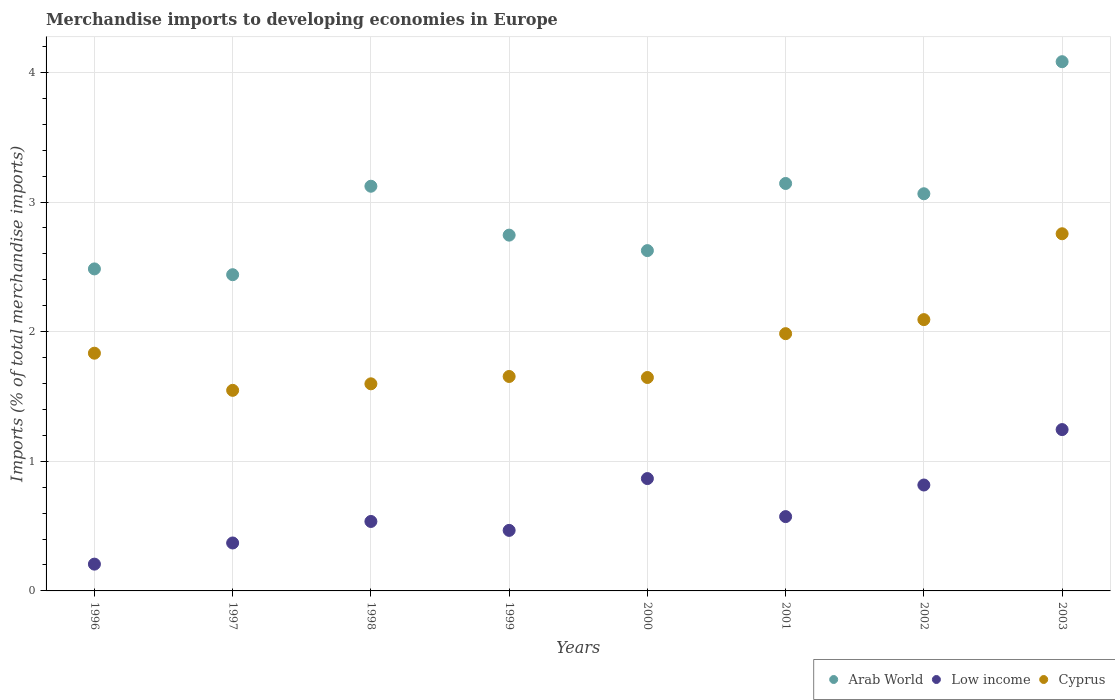How many different coloured dotlines are there?
Offer a very short reply. 3. What is the percentage total merchandise imports in Arab World in 1997?
Your answer should be compact. 2.44. Across all years, what is the maximum percentage total merchandise imports in Cyprus?
Give a very brief answer. 2.76. Across all years, what is the minimum percentage total merchandise imports in Low income?
Your answer should be compact. 0.21. In which year was the percentage total merchandise imports in Low income minimum?
Provide a short and direct response. 1996. What is the total percentage total merchandise imports in Cyprus in the graph?
Ensure brevity in your answer.  15.11. What is the difference between the percentage total merchandise imports in Low income in 1996 and that in 2001?
Offer a very short reply. -0.37. What is the difference between the percentage total merchandise imports in Low income in 2002 and the percentage total merchandise imports in Cyprus in 1996?
Ensure brevity in your answer.  -1.02. What is the average percentage total merchandise imports in Low income per year?
Ensure brevity in your answer.  0.64. In the year 2003, what is the difference between the percentage total merchandise imports in Low income and percentage total merchandise imports in Cyprus?
Your answer should be compact. -1.51. What is the ratio of the percentage total merchandise imports in Low income in 1996 to that in 2003?
Make the answer very short. 0.17. Is the percentage total merchandise imports in Cyprus in 2001 less than that in 2003?
Offer a terse response. Yes. Is the difference between the percentage total merchandise imports in Low income in 1999 and 2003 greater than the difference between the percentage total merchandise imports in Cyprus in 1999 and 2003?
Provide a short and direct response. Yes. What is the difference between the highest and the second highest percentage total merchandise imports in Low income?
Offer a terse response. 0.38. What is the difference between the highest and the lowest percentage total merchandise imports in Low income?
Your response must be concise. 1.04. In how many years, is the percentage total merchandise imports in Cyprus greater than the average percentage total merchandise imports in Cyprus taken over all years?
Keep it short and to the point. 3. Is it the case that in every year, the sum of the percentage total merchandise imports in Arab World and percentage total merchandise imports in Cyprus  is greater than the percentage total merchandise imports in Low income?
Keep it short and to the point. Yes. Does the percentage total merchandise imports in Arab World monotonically increase over the years?
Keep it short and to the point. No. How many dotlines are there?
Your answer should be compact. 3. How many years are there in the graph?
Ensure brevity in your answer.  8. Does the graph contain any zero values?
Ensure brevity in your answer.  No. Where does the legend appear in the graph?
Offer a very short reply. Bottom right. What is the title of the graph?
Your answer should be very brief. Merchandise imports to developing economies in Europe. Does "St. Martin (French part)" appear as one of the legend labels in the graph?
Provide a succinct answer. No. What is the label or title of the Y-axis?
Offer a terse response. Imports (% of total merchandise imports). What is the Imports (% of total merchandise imports) of Arab World in 1996?
Give a very brief answer. 2.48. What is the Imports (% of total merchandise imports) of Low income in 1996?
Offer a very short reply. 0.21. What is the Imports (% of total merchandise imports) in Cyprus in 1996?
Your answer should be compact. 1.83. What is the Imports (% of total merchandise imports) in Arab World in 1997?
Give a very brief answer. 2.44. What is the Imports (% of total merchandise imports) of Low income in 1997?
Keep it short and to the point. 0.37. What is the Imports (% of total merchandise imports) in Cyprus in 1997?
Give a very brief answer. 1.55. What is the Imports (% of total merchandise imports) of Arab World in 1998?
Offer a very short reply. 3.12. What is the Imports (% of total merchandise imports) in Low income in 1998?
Offer a very short reply. 0.54. What is the Imports (% of total merchandise imports) of Cyprus in 1998?
Provide a short and direct response. 1.6. What is the Imports (% of total merchandise imports) in Arab World in 1999?
Offer a very short reply. 2.74. What is the Imports (% of total merchandise imports) in Low income in 1999?
Give a very brief answer. 0.47. What is the Imports (% of total merchandise imports) in Cyprus in 1999?
Your answer should be compact. 1.65. What is the Imports (% of total merchandise imports) in Arab World in 2000?
Offer a very short reply. 2.63. What is the Imports (% of total merchandise imports) in Low income in 2000?
Ensure brevity in your answer.  0.87. What is the Imports (% of total merchandise imports) of Cyprus in 2000?
Keep it short and to the point. 1.65. What is the Imports (% of total merchandise imports) of Arab World in 2001?
Keep it short and to the point. 3.14. What is the Imports (% of total merchandise imports) of Low income in 2001?
Make the answer very short. 0.57. What is the Imports (% of total merchandise imports) of Cyprus in 2001?
Offer a very short reply. 1.98. What is the Imports (% of total merchandise imports) of Arab World in 2002?
Your answer should be compact. 3.06. What is the Imports (% of total merchandise imports) of Low income in 2002?
Offer a very short reply. 0.82. What is the Imports (% of total merchandise imports) in Cyprus in 2002?
Your answer should be compact. 2.09. What is the Imports (% of total merchandise imports) in Arab World in 2003?
Make the answer very short. 4.08. What is the Imports (% of total merchandise imports) in Low income in 2003?
Your answer should be very brief. 1.24. What is the Imports (% of total merchandise imports) of Cyprus in 2003?
Ensure brevity in your answer.  2.76. Across all years, what is the maximum Imports (% of total merchandise imports) of Arab World?
Ensure brevity in your answer.  4.08. Across all years, what is the maximum Imports (% of total merchandise imports) of Low income?
Your answer should be very brief. 1.24. Across all years, what is the maximum Imports (% of total merchandise imports) of Cyprus?
Ensure brevity in your answer.  2.76. Across all years, what is the minimum Imports (% of total merchandise imports) in Arab World?
Ensure brevity in your answer.  2.44. Across all years, what is the minimum Imports (% of total merchandise imports) of Low income?
Make the answer very short. 0.21. Across all years, what is the minimum Imports (% of total merchandise imports) in Cyprus?
Your answer should be very brief. 1.55. What is the total Imports (% of total merchandise imports) of Arab World in the graph?
Offer a very short reply. 23.71. What is the total Imports (% of total merchandise imports) of Low income in the graph?
Offer a very short reply. 5.08. What is the total Imports (% of total merchandise imports) of Cyprus in the graph?
Provide a short and direct response. 15.11. What is the difference between the Imports (% of total merchandise imports) of Arab World in 1996 and that in 1997?
Offer a terse response. 0.04. What is the difference between the Imports (% of total merchandise imports) in Low income in 1996 and that in 1997?
Make the answer very short. -0.16. What is the difference between the Imports (% of total merchandise imports) of Cyprus in 1996 and that in 1997?
Your answer should be compact. 0.29. What is the difference between the Imports (% of total merchandise imports) of Arab World in 1996 and that in 1998?
Make the answer very short. -0.64. What is the difference between the Imports (% of total merchandise imports) of Low income in 1996 and that in 1998?
Your answer should be very brief. -0.33. What is the difference between the Imports (% of total merchandise imports) in Cyprus in 1996 and that in 1998?
Offer a very short reply. 0.24. What is the difference between the Imports (% of total merchandise imports) in Arab World in 1996 and that in 1999?
Keep it short and to the point. -0.26. What is the difference between the Imports (% of total merchandise imports) of Low income in 1996 and that in 1999?
Provide a succinct answer. -0.26. What is the difference between the Imports (% of total merchandise imports) of Cyprus in 1996 and that in 1999?
Your answer should be compact. 0.18. What is the difference between the Imports (% of total merchandise imports) of Arab World in 1996 and that in 2000?
Provide a succinct answer. -0.14. What is the difference between the Imports (% of total merchandise imports) of Low income in 1996 and that in 2000?
Your answer should be very brief. -0.66. What is the difference between the Imports (% of total merchandise imports) in Cyprus in 1996 and that in 2000?
Ensure brevity in your answer.  0.19. What is the difference between the Imports (% of total merchandise imports) of Arab World in 1996 and that in 2001?
Offer a very short reply. -0.66. What is the difference between the Imports (% of total merchandise imports) of Low income in 1996 and that in 2001?
Offer a terse response. -0.37. What is the difference between the Imports (% of total merchandise imports) of Cyprus in 1996 and that in 2001?
Give a very brief answer. -0.15. What is the difference between the Imports (% of total merchandise imports) in Arab World in 1996 and that in 2002?
Provide a succinct answer. -0.58. What is the difference between the Imports (% of total merchandise imports) in Low income in 1996 and that in 2002?
Keep it short and to the point. -0.61. What is the difference between the Imports (% of total merchandise imports) in Cyprus in 1996 and that in 2002?
Your answer should be very brief. -0.26. What is the difference between the Imports (% of total merchandise imports) of Arab World in 1996 and that in 2003?
Provide a short and direct response. -1.6. What is the difference between the Imports (% of total merchandise imports) of Low income in 1996 and that in 2003?
Ensure brevity in your answer.  -1.04. What is the difference between the Imports (% of total merchandise imports) in Cyprus in 1996 and that in 2003?
Provide a short and direct response. -0.92. What is the difference between the Imports (% of total merchandise imports) in Arab World in 1997 and that in 1998?
Your answer should be very brief. -0.68. What is the difference between the Imports (% of total merchandise imports) of Low income in 1997 and that in 1998?
Your answer should be compact. -0.17. What is the difference between the Imports (% of total merchandise imports) in Cyprus in 1997 and that in 1998?
Your answer should be very brief. -0.05. What is the difference between the Imports (% of total merchandise imports) of Arab World in 1997 and that in 1999?
Your response must be concise. -0.31. What is the difference between the Imports (% of total merchandise imports) of Low income in 1997 and that in 1999?
Offer a very short reply. -0.1. What is the difference between the Imports (% of total merchandise imports) of Cyprus in 1997 and that in 1999?
Ensure brevity in your answer.  -0.11. What is the difference between the Imports (% of total merchandise imports) of Arab World in 1997 and that in 2000?
Provide a short and direct response. -0.19. What is the difference between the Imports (% of total merchandise imports) in Low income in 1997 and that in 2000?
Your answer should be compact. -0.5. What is the difference between the Imports (% of total merchandise imports) of Cyprus in 1997 and that in 2000?
Offer a terse response. -0.1. What is the difference between the Imports (% of total merchandise imports) of Arab World in 1997 and that in 2001?
Provide a succinct answer. -0.7. What is the difference between the Imports (% of total merchandise imports) in Low income in 1997 and that in 2001?
Your answer should be very brief. -0.2. What is the difference between the Imports (% of total merchandise imports) of Cyprus in 1997 and that in 2001?
Make the answer very short. -0.44. What is the difference between the Imports (% of total merchandise imports) in Arab World in 1997 and that in 2002?
Provide a short and direct response. -0.62. What is the difference between the Imports (% of total merchandise imports) in Low income in 1997 and that in 2002?
Make the answer very short. -0.45. What is the difference between the Imports (% of total merchandise imports) of Cyprus in 1997 and that in 2002?
Provide a short and direct response. -0.55. What is the difference between the Imports (% of total merchandise imports) in Arab World in 1997 and that in 2003?
Offer a terse response. -1.64. What is the difference between the Imports (% of total merchandise imports) in Low income in 1997 and that in 2003?
Provide a short and direct response. -0.87. What is the difference between the Imports (% of total merchandise imports) of Cyprus in 1997 and that in 2003?
Offer a terse response. -1.21. What is the difference between the Imports (% of total merchandise imports) of Arab World in 1998 and that in 1999?
Offer a very short reply. 0.38. What is the difference between the Imports (% of total merchandise imports) in Low income in 1998 and that in 1999?
Keep it short and to the point. 0.07. What is the difference between the Imports (% of total merchandise imports) in Cyprus in 1998 and that in 1999?
Your answer should be very brief. -0.06. What is the difference between the Imports (% of total merchandise imports) of Arab World in 1998 and that in 2000?
Ensure brevity in your answer.  0.5. What is the difference between the Imports (% of total merchandise imports) of Low income in 1998 and that in 2000?
Provide a short and direct response. -0.33. What is the difference between the Imports (% of total merchandise imports) in Cyprus in 1998 and that in 2000?
Your answer should be compact. -0.05. What is the difference between the Imports (% of total merchandise imports) in Arab World in 1998 and that in 2001?
Provide a succinct answer. -0.02. What is the difference between the Imports (% of total merchandise imports) of Low income in 1998 and that in 2001?
Give a very brief answer. -0.04. What is the difference between the Imports (% of total merchandise imports) in Cyprus in 1998 and that in 2001?
Your response must be concise. -0.39. What is the difference between the Imports (% of total merchandise imports) of Arab World in 1998 and that in 2002?
Your answer should be very brief. 0.06. What is the difference between the Imports (% of total merchandise imports) of Low income in 1998 and that in 2002?
Offer a very short reply. -0.28. What is the difference between the Imports (% of total merchandise imports) in Cyprus in 1998 and that in 2002?
Provide a succinct answer. -0.5. What is the difference between the Imports (% of total merchandise imports) of Arab World in 1998 and that in 2003?
Provide a succinct answer. -0.96. What is the difference between the Imports (% of total merchandise imports) of Low income in 1998 and that in 2003?
Keep it short and to the point. -0.71. What is the difference between the Imports (% of total merchandise imports) in Cyprus in 1998 and that in 2003?
Offer a very short reply. -1.16. What is the difference between the Imports (% of total merchandise imports) of Arab World in 1999 and that in 2000?
Offer a very short reply. 0.12. What is the difference between the Imports (% of total merchandise imports) in Low income in 1999 and that in 2000?
Give a very brief answer. -0.4. What is the difference between the Imports (% of total merchandise imports) in Cyprus in 1999 and that in 2000?
Keep it short and to the point. 0.01. What is the difference between the Imports (% of total merchandise imports) in Arab World in 1999 and that in 2001?
Your answer should be very brief. -0.4. What is the difference between the Imports (% of total merchandise imports) of Low income in 1999 and that in 2001?
Give a very brief answer. -0.11. What is the difference between the Imports (% of total merchandise imports) in Cyprus in 1999 and that in 2001?
Make the answer very short. -0.33. What is the difference between the Imports (% of total merchandise imports) of Arab World in 1999 and that in 2002?
Your response must be concise. -0.32. What is the difference between the Imports (% of total merchandise imports) in Low income in 1999 and that in 2002?
Your answer should be very brief. -0.35. What is the difference between the Imports (% of total merchandise imports) in Cyprus in 1999 and that in 2002?
Give a very brief answer. -0.44. What is the difference between the Imports (% of total merchandise imports) in Arab World in 1999 and that in 2003?
Ensure brevity in your answer.  -1.34. What is the difference between the Imports (% of total merchandise imports) of Low income in 1999 and that in 2003?
Keep it short and to the point. -0.78. What is the difference between the Imports (% of total merchandise imports) in Cyprus in 1999 and that in 2003?
Provide a succinct answer. -1.1. What is the difference between the Imports (% of total merchandise imports) of Arab World in 2000 and that in 2001?
Provide a succinct answer. -0.52. What is the difference between the Imports (% of total merchandise imports) of Low income in 2000 and that in 2001?
Make the answer very short. 0.29. What is the difference between the Imports (% of total merchandise imports) in Cyprus in 2000 and that in 2001?
Make the answer very short. -0.34. What is the difference between the Imports (% of total merchandise imports) of Arab World in 2000 and that in 2002?
Provide a short and direct response. -0.44. What is the difference between the Imports (% of total merchandise imports) in Low income in 2000 and that in 2002?
Make the answer very short. 0.05. What is the difference between the Imports (% of total merchandise imports) of Cyprus in 2000 and that in 2002?
Make the answer very short. -0.45. What is the difference between the Imports (% of total merchandise imports) of Arab World in 2000 and that in 2003?
Your answer should be very brief. -1.46. What is the difference between the Imports (% of total merchandise imports) in Low income in 2000 and that in 2003?
Your response must be concise. -0.38. What is the difference between the Imports (% of total merchandise imports) of Cyprus in 2000 and that in 2003?
Provide a short and direct response. -1.11. What is the difference between the Imports (% of total merchandise imports) of Arab World in 2001 and that in 2002?
Keep it short and to the point. 0.08. What is the difference between the Imports (% of total merchandise imports) of Low income in 2001 and that in 2002?
Make the answer very short. -0.24. What is the difference between the Imports (% of total merchandise imports) of Cyprus in 2001 and that in 2002?
Your answer should be very brief. -0.11. What is the difference between the Imports (% of total merchandise imports) in Arab World in 2001 and that in 2003?
Offer a very short reply. -0.94. What is the difference between the Imports (% of total merchandise imports) of Low income in 2001 and that in 2003?
Offer a very short reply. -0.67. What is the difference between the Imports (% of total merchandise imports) in Cyprus in 2001 and that in 2003?
Offer a terse response. -0.77. What is the difference between the Imports (% of total merchandise imports) of Arab World in 2002 and that in 2003?
Provide a short and direct response. -1.02. What is the difference between the Imports (% of total merchandise imports) in Low income in 2002 and that in 2003?
Keep it short and to the point. -0.43. What is the difference between the Imports (% of total merchandise imports) of Cyprus in 2002 and that in 2003?
Your answer should be very brief. -0.66. What is the difference between the Imports (% of total merchandise imports) of Arab World in 1996 and the Imports (% of total merchandise imports) of Low income in 1997?
Your response must be concise. 2.11. What is the difference between the Imports (% of total merchandise imports) in Arab World in 1996 and the Imports (% of total merchandise imports) in Cyprus in 1997?
Your answer should be compact. 0.94. What is the difference between the Imports (% of total merchandise imports) in Low income in 1996 and the Imports (% of total merchandise imports) in Cyprus in 1997?
Ensure brevity in your answer.  -1.34. What is the difference between the Imports (% of total merchandise imports) in Arab World in 1996 and the Imports (% of total merchandise imports) in Low income in 1998?
Your answer should be compact. 1.95. What is the difference between the Imports (% of total merchandise imports) of Arab World in 1996 and the Imports (% of total merchandise imports) of Cyprus in 1998?
Provide a succinct answer. 0.89. What is the difference between the Imports (% of total merchandise imports) of Low income in 1996 and the Imports (% of total merchandise imports) of Cyprus in 1998?
Your answer should be compact. -1.39. What is the difference between the Imports (% of total merchandise imports) in Arab World in 1996 and the Imports (% of total merchandise imports) in Low income in 1999?
Provide a succinct answer. 2.02. What is the difference between the Imports (% of total merchandise imports) in Arab World in 1996 and the Imports (% of total merchandise imports) in Cyprus in 1999?
Ensure brevity in your answer.  0.83. What is the difference between the Imports (% of total merchandise imports) of Low income in 1996 and the Imports (% of total merchandise imports) of Cyprus in 1999?
Give a very brief answer. -1.45. What is the difference between the Imports (% of total merchandise imports) in Arab World in 1996 and the Imports (% of total merchandise imports) in Low income in 2000?
Your answer should be compact. 1.62. What is the difference between the Imports (% of total merchandise imports) in Arab World in 1996 and the Imports (% of total merchandise imports) in Cyprus in 2000?
Offer a very short reply. 0.84. What is the difference between the Imports (% of total merchandise imports) of Low income in 1996 and the Imports (% of total merchandise imports) of Cyprus in 2000?
Give a very brief answer. -1.44. What is the difference between the Imports (% of total merchandise imports) of Arab World in 1996 and the Imports (% of total merchandise imports) of Low income in 2001?
Your response must be concise. 1.91. What is the difference between the Imports (% of total merchandise imports) of Arab World in 1996 and the Imports (% of total merchandise imports) of Cyprus in 2001?
Your answer should be very brief. 0.5. What is the difference between the Imports (% of total merchandise imports) of Low income in 1996 and the Imports (% of total merchandise imports) of Cyprus in 2001?
Your answer should be very brief. -1.78. What is the difference between the Imports (% of total merchandise imports) in Arab World in 1996 and the Imports (% of total merchandise imports) in Low income in 2002?
Make the answer very short. 1.67. What is the difference between the Imports (% of total merchandise imports) of Arab World in 1996 and the Imports (% of total merchandise imports) of Cyprus in 2002?
Offer a very short reply. 0.39. What is the difference between the Imports (% of total merchandise imports) of Low income in 1996 and the Imports (% of total merchandise imports) of Cyprus in 2002?
Provide a succinct answer. -1.89. What is the difference between the Imports (% of total merchandise imports) of Arab World in 1996 and the Imports (% of total merchandise imports) of Low income in 2003?
Make the answer very short. 1.24. What is the difference between the Imports (% of total merchandise imports) of Arab World in 1996 and the Imports (% of total merchandise imports) of Cyprus in 2003?
Your answer should be very brief. -0.27. What is the difference between the Imports (% of total merchandise imports) of Low income in 1996 and the Imports (% of total merchandise imports) of Cyprus in 2003?
Your response must be concise. -2.55. What is the difference between the Imports (% of total merchandise imports) of Arab World in 1997 and the Imports (% of total merchandise imports) of Low income in 1998?
Your response must be concise. 1.9. What is the difference between the Imports (% of total merchandise imports) of Arab World in 1997 and the Imports (% of total merchandise imports) of Cyprus in 1998?
Your response must be concise. 0.84. What is the difference between the Imports (% of total merchandise imports) of Low income in 1997 and the Imports (% of total merchandise imports) of Cyprus in 1998?
Your answer should be very brief. -1.23. What is the difference between the Imports (% of total merchandise imports) of Arab World in 1997 and the Imports (% of total merchandise imports) of Low income in 1999?
Provide a succinct answer. 1.97. What is the difference between the Imports (% of total merchandise imports) of Arab World in 1997 and the Imports (% of total merchandise imports) of Cyprus in 1999?
Your response must be concise. 0.79. What is the difference between the Imports (% of total merchandise imports) in Low income in 1997 and the Imports (% of total merchandise imports) in Cyprus in 1999?
Make the answer very short. -1.28. What is the difference between the Imports (% of total merchandise imports) in Arab World in 1997 and the Imports (% of total merchandise imports) in Low income in 2000?
Offer a very short reply. 1.57. What is the difference between the Imports (% of total merchandise imports) of Arab World in 1997 and the Imports (% of total merchandise imports) of Cyprus in 2000?
Offer a terse response. 0.79. What is the difference between the Imports (% of total merchandise imports) of Low income in 1997 and the Imports (% of total merchandise imports) of Cyprus in 2000?
Provide a short and direct response. -1.28. What is the difference between the Imports (% of total merchandise imports) in Arab World in 1997 and the Imports (% of total merchandise imports) in Low income in 2001?
Your answer should be very brief. 1.87. What is the difference between the Imports (% of total merchandise imports) in Arab World in 1997 and the Imports (% of total merchandise imports) in Cyprus in 2001?
Offer a terse response. 0.45. What is the difference between the Imports (% of total merchandise imports) of Low income in 1997 and the Imports (% of total merchandise imports) of Cyprus in 2001?
Ensure brevity in your answer.  -1.61. What is the difference between the Imports (% of total merchandise imports) in Arab World in 1997 and the Imports (% of total merchandise imports) in Low income in 2002?
Make the answer very short. 1.62. What is the difference between the Imports (% of total merchandise imports) of Arab World in 1997 and the Imports (% of total merchandise imports) of Cyprus in 2002?
Ensure brevity in your answer.  0.35. What is the difference between the Imports (% of total merchandise imports) in Low income in 1997 and the Imports (% of total merchandise imports) in Cyprus in 2002?
Offer a very short reply. -1.72. What is the difference between the Imports (% of total merchandise imports) of Arab World in 1997 and the Imports (% of total merchandise imports) of Low income in 2003?
Offer a very short reply. 1.19. What is the difference between the Imports (% of total merchandise imports) of Arab World in 1997 and the Imports (% of total merchandise imports) of Cyprus in 2003?
Provide a succinct answer. -0.32. What is the difference between the Imports (% of total merchandise imports) in Low income in 1997 and the Imports (% of total merchandise imports) in Cyprus in 2003?
Your response must be concise. -2.39. What is the difference between the Imports (% of total merchandise imports) in Arab World in 1998 and the Imports (% of total merchandise imports) in Low income in 1999?
Ensure brevity in your answer.  2.66. What is the difference between the Imports (% of total merchandise imports) in Arab World in 1998 and the Imports (% of total merchandise imports) in Cyprus in 1999?
Your answer should be very brief. 1.47. What is the difference between the Imports (% of total merchandise imports) of Low income in 1998 and the Imports (% of total merchandise imports) of Cyprus in 1999?
Provide a short and direct response. -1.12. What is the difference between the Imports (% of total merchandise imports) in Arab World in 1998 and the Imports (% of total merchandise imports) in Low income in 2000?
Offer a terse response. 2.26. What is the difference between the Imports (% of total merchandise imports) in Arab World in 1998 and the Imports (% of total merchandise imports) in Cyprus in 2000?
Offer a very short reply. 1.48. What is the difference between the Imports (% of total merchandise imports) of Low income in 1998 and the Imports (% of total merchandise imports) of Cyprus in 2000?
Offer a very short reply. -1.11. What is the difference between the Imports (% of total merchandise imports) in Arab World in 1998 and the Imports (% of total merchandise imports) in Low income in 2001?
Provide a succinct answer. 2.55. What is the difference between the Imports (% of total merchandise imports) of Arab World in 1998 and the Imports (% of total merchandise imports) of Cyprus in 2001?
Ensure brevity in your answer.  1.14. What is the difference between the Imports (% of total merchandise imports) of Low income in 1998 and the Imports (% of total merchandise imports) of Cyprus in 2001?
Provide a succinct answer. -1.45. What is the difference between the Imports (% of total merchandise imports) of Arab World in 1998 and the Imports (% of total merchandise imports) of Low income in 2002?
Your response must be concise. 2.31. What is the difference between the Imports (% of total merchandise imports) of Arab World in 1998 and the Imports (% of total merchandise imports) of Cyprus in 2002?
Make the answer very short. 1.03. What is the difference between the Imports (% of total merchandise imports) in Low income in 1998 and the Imports (% of total merchandise imports) in Cyprus in 2002?
Your answer should be compact. -1.56. What is the difference between the Imports (% of total merchandise imports) in Arab World in 1998 and the Imports (% of total merchandise imports) in Low income in 2003?
Give a very brief answer. 1.88. What is the difference between the Imports (% of total merchandise imports) in Arab World in 1998 and the Imports (% of total merchandise imports) in Cyprus in 2003?
Offer a terse response. 0.37. What is the difference between the Imports (% of total merchandise imports) of Low income in 1998 and the Imports (% of total merchandise imports) of Cyprus in 2003?
Your answer should be compact. -2.22. What is the difference between the Imports (% of total merchandise imports) in Arab World in 1999 and the Imports (% of total merchandise imports) in Low income in 2000?
Keep it short and to the point. 1.88. What is the difference between the Imports (% of total merchandise imports) in Arab World in 1999 and the Imports (% of total merchandise imports) in Cyprus in 2000?
Keep it short and to the point. 1.1. What is the difference between the Imports (% of total merchandise imports) in Low income in 1999 and the Imports (% of total merchandise imports) in Cyprus in 2000?
Ensure brevity in your answer.  -1.18. What is the difference between the Imports (% of total merchandise imports) of Arab World in 1999 and the Imports (% of total merchandise imports) of Low income in 2001?
Make the answer very short. 2.17. What is the difference between the Imports (% of total merchandise imports) in Arab World in 1999 and the Imports (% of total merchandise imports) in Cyprus in 2001?
Ensure brevity in your answer.  0.76. What is the difference between the Imports (% of total merchandise imports) of Low income in 1999 and the Imports (% of total merchandise imports) of Cyprus in 2001?
Your answer should be very brief. -1.52. What is the difference between the Imports (% of total merchandise imports) of Arab World in 1999 and the Imports (% of total merchandise imports) of Low income in 2002?
Provide a short and direct response. 1.93. What is the difference between the Imports (% of total merchandise imports) of Arab World in 1999 and the Imports (% of total merchandise imports) of Cyprus in 2002?
Your answer should be compact. 0.65. What is the difference between the Imports (% of total merchandise imports) in Low income in 1999 and the Imports (% of total merchandise imports) in Cyprus in 2002?
Your response must be concise. -1.63. What is the difference between the Imports (% of total merchandise imports) of Arab World in 1999 and the Imports (% of total merchandise imports) of Low income in 2003?
Offer a very short reply. 1.5. What is the difference between the Imports (% of total merchandise imports) in Arab World in 1999 and the Imports (% of total merchandise imports) in Cyprus in 2003?
Your answer should be compact. -0.01. What is the difference between the Imports (% of total merchandise imports) of Low income in 1999 and the Imports (% of total merchandise imports) of Cyprus in 2003?
Make the answer very short. -2.29. What is the difference between the Imports (% of total merchandise imports) of Arab World in 2000 and the Imports (% of total merchandise imports) of Low income in 2001?
Provide a short and direct response. 2.05. What is the difference between the Imports (% of total merchandise imports) in Arab World in 2000 and the Imports (% of total merchandise imports) in Cyprus in 2001?
Provide a succinct answer. 0.64. What is the difference between the Imports (% of total merchandise imports) in Low income in 2000 and the Imports (% of total merchandise imports) in Cyprus in 2001?
Make the answer very short. -1.12. What is the difference between the Imports (% of total merchandise imports) in Arab World in 2000 and the Imports (% of total merchandise imports) in Low income in 2002?
Your answer should be very brief. 1.81. What is the difference between the Imports (% of total merchandise imports) of Arab World in 2000 and the Imports (% of total merchandise imports) of Cyprus in 2002?
Your answer should be compact. 0.53. What is the difference between the Imports (% of total merchandise imports) of Low income in 2000 and the Imports (% of total merchandise imports) of Cyprus in 2002?
Provide a short and direct response. -1.23. What is the difference between the Imports (% of total merchandise imports) of Arab World in 2000 and the Imports (% of total merchandise imports) of Low income in 2003?
Make the answer very short. 1.38. What is the difference between the Imports (% of total merchandise imports) in Arab World in 2000 and the Imports (% of total merchandise imports) in Cyprus in 2003?
Ensure brevity in your answer.  -0.13. What is the difference between the Imports (% of total merchandise imports) of Low income in 2000 and the Imports (% of total merchandise imports) of Cyprus in 2003?
Offer a very short reply. -1.89. What is the difference between the Imports (% of total merchandise imports) of Arab World in 2001 and the Imports (% of total merchandise imports) of Low income in 2002?
Provide a succinct answer. 2.33. What is the difference between the Imports (% of total merchandise imports) in Arab World in 2001 and the Imports (% of total merchandise imports) in Cyprus in 2002?
Give a very brief answer. 1.05. What is the difference between the Imports (% of total merchandise imports) of Low income in 2001 and the Imports (% of total merchandise imports) of Cyprus in 2002?
Your answer should be very brief. -1.52. What is the difference between the Imports (% of total merchandise imports) in Arab World in 2001 and the Imports (% of total merchandise imports) in Low income in 2003?
Make the answer very short. 1.9. What is the difference between the Imports (% of total merchandise imports) of Arab World in 2001 and the Imports (% of total merchandise imports) of Cyprus in 2003?
Your answer should be compact. 0.39. What is the difference between the Imports (% of total merchandise imports) of Low income in 2001 and the Imports (% of total merchandise imports) of Cyprus in 2003?
Keep it short and to the point. -2.18. What is the difference between the Imports (% of total merchandise imports) of Arab World in 2002 and the Imports (% of total merchandise imports) of Low income in 2003?
Provide a succinct answer. 1.82. What is the difference between the Imports (% of total merchandise imports) of Arab World in 2002 and the Imports (% of total merchandise imports) of Cyprus in 2003?
Offer a terse response. 0.31. What is the difference between the Imports (% of total merchandise imports) in Low income in 2002 and the Imports (% of total merchandise imports) in Cyprus in 2003?
Provide a succinct answer. -1.94. What is the average Imports (% of total merchandise imports) in Arab World per year?
Keep it short and to the point. 2.96. What is the average Imports (% of total merchandise imports) of Low income per year?
Ensure brevity in your answer.  0.64. What is the average Imports (% of total merchandise imports) of Cyprus per year?
Your answer should be very brief. 1.89. In the year 1996, what is the difference between the Imports (% of total merchandise imports) of Arab World and Imports (% of total merchandise imports) of Low income?
Offer a terse response. 2.28. In the year 1996, what is the difference between the Imports (% of total merchandise imports) in Arab World and Imports (% of total merchandise imports) in Cyprus?
Your answer should be compact. 0.65. In the year 1996, what is the difference between the Imports (% of total merchandise imports) of Low income and Imports (% of total merchandise imports) of Cyprus?
Provide a succinct answer. -1.63. In the year 1997, what is the difference between the Imports (% of total merchandise imports) in Arab World and Imports (% of total merchandise imports) in Low income?
Give a very brief answer. 2.07. In the year 1997, what is the difference between the Imports (% of total merchandise imports) of Arab World and Imports (% of total merchandise imports) of Cyprus?
Your answer should be very brief. 0.89. In the year 1997, what is the difference between the Imports (% of total merchandise imports) in Low income and Imports (% of total merchandise imports) in Cyprus?
Ensure brevity in your answer.  -1.18. In the year 1998, what is the difference between the Imports (% of total merchandise imports) of Arab World and Imports (% of total merchandise imports) of Low income?
Ensure brevity in your answer.  2.59. In the year 1998, what is the difference between the Imports (% of total merchandise imports) in Arab World and Imports (% of total merchandise imports) in Cyprus?
Your answer should be compact. 1.52. In the year 1998, what is the difference between the Imports (% of total merchandise imports) in Low income and Imports (% of total merchandise imports) in Cyprus?
Keep it short and to the point. -1.06. In the year 1999, what is the difference between the Imports (% of total merchandise imports) in Arab World and Imports (% of total merchandise imports) in Low income?
Provide a short and direct response. 2.28. In the year 1999, what is the difference between the Imports (% of total merchandise imports) of Arab World and Imports (% of total merchandise imports) of Cyprus?
Keep it short and to the point. 1.09. In the year 1999, what is the difference between the Imports (% of total merchandise imports) in Low income and Imports (% of total merchandise imports) in Cyprus?
Make the answer very short. -1.19. In the year 2000, what is the difference between the Imports (% of total merchandise imports) in Arab World and Imports (% of total merchandise imports) in Low income?
Ensure brevity in your answer.  1.76. In the year 2000, what is the difference between the Imports (% of total merchandise imports) of Low income and Imports (% of total merchandise imports) of Cyprus?
Provide a short and direct response. -0.78. In the year 2001, what is the difference between the Imports (% of total merchandise imports) in Arab World and Imports (% of total merchandise imports) in Low income?
Offer a terse response. 2.57. In the year 2001, what is the difference between the Imports (% of total merchandise imports) in Arab World and Imports (% of total merchandise imports) in Cyprus?
Offer a very short reply. 1.16. In the year 2001, what is the difference between the Imports (% of total merchandise imports) of Low income and Imports (% of total merchandise imports) of Cyprus?
Give a very brief answer. -1.41. In the year 2002, what is the difference between the Imports (% of total merchandise imports) in Arab World and Imports (% of total merchandise imports) in Low income?
Offer a very short reply. 2.25. In the year 2002, what is the difference between the Imports (% of total merchandise imports) of Arab World and Imports (% of total merchandise imports) of Cyprus?
Your response must be concise. 0.97. In the year 2002, what is the difference between the Imports (% of total merchandise imports) in Low income and Imports (% of total merchandise imports) in Cyprus?
Provide a succinct answer. -1.28. In the year 2003, what is the difference between the Imports (% of total merchandise imports) in Arab World and Imports (% of total merchandise imports) in Low income?
Ensure brevity in your answer.  2.84. In the year 2003, what is the difference between the Imports (% of total merchandise imports) in Arab World and Imports (% of total merchandise imports) in Cyprus?
Keep it short and to the point. 1.33. In the year 2003, what is the difference between the Imports (% of total merchandise imports) in Low income and Imports (% of total merchandise imports) in Cyprus?
Your answer should be very brief. -1.51. What is the ratio of the Imports (% of total merchandise imports) in Arab World in 1996 to that in 1997?
Make the answer very short. 1.02. What is the ratio of the Imports (% of total merchandise imports) in Low income in 1996 to that in 1997?
Your answer should be very brief. 0.56. What is the ratio of the Imports (% of total merchandise imports) of Cyprus in 1996 to that in 1997?
Your answer should be compact. 1.19. What is the ratio of the Imports (% of total merchandise imports) in Arab World in 1996 to that in 1998?
Offer a very short reply. 0.8. What is the ratio of the Imports (% of total merchandise imports) of Low income in 1996 to that in 1998?
Keep it short and to the point. 0.39. What is the ratio of the Imports (% of total merchandise imports) in Cyprus in 1996 to that in 1998?
Provide a succinct answer. 1.15. What is the ratio of the Imports (% of total merchandise imports) of Arab World in 1996 to that in 1999?
Ensure brevity in your answer.  0.91. What is the ratio of the Imports (% of total merchandise imports) in Low income in 1996 to that in 1999?
Provide a succinct answer. 0.44. What is the ratio of the Imports (% of total merchandise imports) of Cyprus in 1996 to that in 1999?
Your response must be concise. 1.11. What is the ratio of the Imports (% of total merchandise imports) of Arab World in 1996 to that in 2000?
Offer a terse response. 0.95. What is the ratio of the Imports (% of total merchandise imports) of Low income in 1996 to that in 2000?
Provide a short and direct response. 0.24. What is the ratio of the Imports (% of total merchandise imports) of Cyprus in 1996 to that in 2000?
Your response must be concise. 1.11. What is the ratio of the Imports (% of total merchandise imports) of Arab World in 1996 to that in 2001?
Provide a short and direct response. 0.79. What is the ratio of the Imports (% of total merchandise imports) in Low income in 1996 to that in 2001?
Offer a very short reply. 0.36. What is the ratio of the Imports (% of total merchandise imports) of Cyprus in 1996 to that in 2001?
Ensure brevity in your answer.  0.92. What is the ratio of the Imports (% of total merchandise imports) of Arab World in 1996 to that in 2002?
Your answer should be compact. 0.81. What is the ratio of the Imports (% of total merchandise imports) in Low income in 1996 to that in 2002?
Make the answer very short. 0.25. What is the ratio of the Imports (% of total merchandise imports) of Cyprus in 1996 to that in 2002?
Give a very brief answer. 0.88. What is the ratio of the Imports (% of total merchandise imports) in Arab World in 1996 to that in 2003?
Your answer should be compact. 0.61. What is the ratio of the Imports (% of total merchandise imports) in Low income in 1996 to that in 2003?
Offer a very short reply. 0.17. What is the ratio of the Imports (% of total merchandise imports) of Cyprus in 1996 to that in 2003?
Your answer should be very brief. 0.67. What is the ratio of the Imports (% of total merchandise imports) in Arab World in 1997 to that in 1998?
Your response must be concise. 0.78. What is the ratio of the Imports (% of total merchandise imports) of Low income in 1997 to that in 1998?
Offer a very short reply. 0.69. What is the ratio of the Imports (% of total merchandise imports) of Cyprus in 1997 to that in 1998?
Ensure brevity in your answer.  0.97. What is the ratio of the Imports (% of total merchandise imports) in Arab World in 1997 to that in 1999?
Offer a very short reply. 0.89. What is the ratio of the Imports (% of total merchandise imports) of Low income in 1997 to that in 1999?
Keep it short and to the point. 0.79. What is the ratio of the Imports (% of total merchandise imports) of Cyprus in 1997 to that in 1999?
Give a very brief answer. 0.94. What is the ratio of the Imports (% of total merchandise imports) in Arab World in 1997 to that in 2000?
Your response must be concise. 0.93. What is the ratio of the Imports (% of total merchandise imports) of Low income in 1997 to that in 2000?
Provide a short and direct response. 0.43. What is the ratio of the Imports (% of total merchandise imports) of Cyprus in 1997 to that in 2000?
Make the answer very short. 0.94. What is the ratio of the Imports (% of total merchandise imports) in Arab World in 1997 to that in 2001?
Keep it short and to the point. 0.78. What is the ratio of the Imports (% of total merchandise imports) of Low income in 1997 to that in 2001?
Your answer should be very brief. 0.65. What is the ratio of the Imports (% of total merchandise imports) of Cyprus in 1997 to that in 2001?
Provide a succinct answer. 0.78. What is the ratio of the Imports (% of total merchandise imports) in Arab World in 1997 to that in 2002?
Ensure brevity in your answer.  0.8. What is the ratio of the Imports (% of total merchandise imports) of Low income in 1997 to that in 2002?
Keep it short and to the point. 0.45. What is the ratio of the Imports (% of total merchandise imports) in Cyprus in 1997 to that in 2002?
Your answer should be compact. 0.74. What is the ratio of the Imports (% of total merchandise imports) of Arab World in 1997 to that in 2003?
Your response must be concise. 0.6. What is the ratio of the Imports (% of total merchandise imports) in Low income in 1997 to that in 2003?
Ensure brevity in your answer.  0.3. What is the ratio of the Imports (% of total merchandise imports) of Cyprus in 1997 to that in 2003?
Give a very brief answer. 0.56. What is the ratio of the Imports (% of total merchandise imports) of Arab World in 1998 to that in 1999?
Offer a terse response. 1.14. What is the ratio of the Imports (% of total merchandise imports) in Low income in 1998 to that in 1999?
Keep it short and to the point. 1.15. What is the ratio of the Imports (% of total merchandise imports) of Cyprus in 1998 to that in 1999?
Offer a terse response. 0.97. What is the ratio of the Imports (% of total merchandise imports) of Arab World in 1998 to that in 2000?
Offer a very short reply. 1.19. What is the ratio of the Imports (% of total merchandise imports) of Low income in 1998 to that in 2000?
Keep it short and to the point. 0.62. What is the ratio of the Imports (% of total merchandise imports) in Cyprus in 1998 to that in 2000?
Your response must be concise. 0.97. What is the ratio of the Imports (% of total merchandise imports) of Low income in 1998 to that in 2001?
Your answer should be compact. 0.93. What is the ratio of the Imports (% of total merchandise imports) in Cyprus in 1998 to that in 2001?
Your answer should be very brief. 0.81. What is the ratio of the Imports (% of total merchandise imports) in Arab World in 1998 to that in 2002?
Your response must be concise. 1.02. What is the ratio of the Imports (% of total merchandise imports) of Low income in 1998 to that in 2002?
Offer a terse response. 0.66. What is the ratio of the Imports (% of total merchandise imports) in Cyprus in 1998 to that in 2002?
Offer a terse response. 0.76. What is the ratio of the Imports (% of total merchandise imports) in Arab World in 1998 to that in 2003?
Your answer should be very brief. 0.76. What is the ratio of the Imports (% of total merchandise imports) in Low income in 1998 to that in 2003?
Keep it short and to the point. 0.43. What is the ratio of the Imports (% of total merchandise imports) in Cyprus in 1998 to that in 2003?
Provide a succinct answer. 0.58. What is the ratio of the Imports (% of total merchandise imports) in Arab World in 1999 to that in 2000?
Offer a terse response. 1.05. What is the ratio of the Imports (% of total merchandise imports) in Low income in 1999 to that in 2000?
Your answer should be very brief. 0.54. What is the ratio of the Imports (% of total merchandise imports) of Cyprus in 1999 to that in 2000?
Make the answer very short. 1. What is the ratio of the Imports (% of total merchandise imports) in Arab World in 1999 to that in 2001?
Offer a terse response. 0.87. What is the ratio of the Imports (% of total merchandise imports) of Low income in 1999 to that in 2001?
Offer a very short reply. 0.81. What is the ratio of the Imports (% of total merchandise imports) in Cyprus in 1999 to that in 2001?
Offer a very short reply. 0.83. What is the ratio of the Imports (% of total merchandise imports) of Arab World in 1999 to that in 2002?
Keep it short and to the point. 0.9. What is the ratio of the Imports (% of total merchandise imports) of Low income in 1999 to that in 2002?
Your response must be concise. 0.57. What is the ratio of the Imports (% of total merchandise imports) of Cyprus in 1999 to that in 2002?
Your response must be concise. 0.79. What is the ratio of the Imports (% of total merchandise imports) of Arab World in 1999 to that in 2003?
Make the answer very short. 0.67. What is the ratio of the Imports (% of total merchandise imports) in Low income in 1999 to that in 2003?
Provide a short and direct response. 0.38. What is the ratio of the Imports (% of total merchandise imports) in Cyprus in 1999 to that in 2003?
Provide a short and direct response. 0.6. What is the ratio of the Imports (% of total merchandise imports) of Arab World in 2000 to that in 2001?
Offer a very short reply. 0.84. What is the ratio of the Imports (% of total merchandise imports) of Low income in 2000 to that in 2001?
Give a very brief answer. 1.51. What is the ratio of the Imports (% of total merchandise imports) of Cyprus in 2000 to that in 2001?
Ensure brevity in your answer.  0.83. What is the ratio of the Imports (% of total merchandise imports) of Arab World in 2000 to that in 2002?
Ensure brevity in your answer.  0.86. What is the ratio of the Imports (% of total merchandise imports) of Low income in 2000 to that in 2002?
Offer a very short reply. 1.06. What is the ratio of the Imports (% of total merchandise imports) of Cyprus in 2000 to that in 2002?
Offer a very short reply. 0.79. What is the ratio of the Imports (% of total merchandise imports) of Arab World in 2000 to that in 2003?
Ensure brevity in your answer.  0.64. What is the ratio of the Imports (% of total merchandise imports) in Low income in 2000 to that in 2003?
Give a very brief answer. 0.7. What is the ratio of the Imports (% of total merchandise imports) in Cyprus in 2000 to that in 2003?
Offer a very short reply. 0.6. What is the ratio of the Imports (% of total merchandise imports) of Arab World in 2001 to that in 2002?
Ensure brevity in your answer.  1.03. What is the ratio of the Imports (% of total merchandise imports) in Low income in 2001 to that in 2002?
Offer a terse response. 0.7. What is the ratio of the Imports (% of total merchandise imports) in Cyprus in 2001 to that in 2002?
Provide a short and direct response. 0.95. What is the ratio of the Imports (% of total merchandise imports) in Arab World in 2001 to that in 2003?
Give a very brief answer. 0.77. What is the ratio of the Imports (% of total merchandise imports) of Low income in 2001 to that in 2003?
Your answer should be compact. 0.46. What is the ratio of the Imports (% of total merchandise imports) of Cyprus in 2001 to that in 2003?
Offer a terse response. 0.72. What is the ratio of the Imports (% of total merchandise imports) of Arab World in 2002 to that in 2003?
Keep it short and to the point. 0.75. What is the ratio of the Imports (% of total merchandise imports) in Low income in 2002 to that in 2003?
Give a very brief answer. 0.66. What is the ratio of the Imports (% of total merchandise imports) in Cyprus in 2002 to that in 2003?
Keep it short and to the point. 0.76. What is the difference between the highest and the second highest Imports (% of total merchandise imports) of Arab World?
Make the answer very short. 0.94. What is the difference between the highest and the second highest Imports (% of total merchandise imports) of Low income?
Offer a very short reply. 0.38. What is the difference between the highest and the second highest Imports (% of total merchandise imports) in Cyprus?
Offer a terse response. 0.66. What is the difference between the highest and the lowest Imports (% of total merchandise imports) in Arab World?
Provide a short and direct response. 1.64. What is the difference between the highest and the lowest Imports (% of total merchandise imports) of Low income?
Make the answer very short. 1.04. What is the difference between the highest and the lowest Imports (% of total merchandise imports) of Cyprus?
Your answer should be compact. 1.21. 